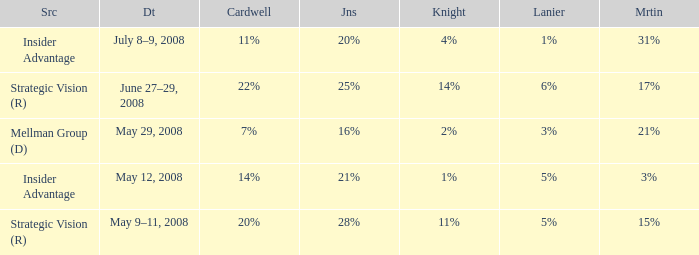What cardwell has an insider advantage and a knight of 1% 14%. I'm looking to parse the entire table for insights. Could you assist me with that? {'header': ['Src', 'Dt', 'Cardwell', 'Jns', 'Knight', 'Lanier', 'Mrtin'], 'rows': [['Insider Advantage', 'July 8–9, 2008', '11%', '20%', '4%', '1%', '31%'], ['Strategic Vision (R)', 'June 27–29, 2008', '22%', '25%', '14%', '6%', '17%'], ['Mellman Group (D)', 'May 29, 2008', '7%', '16%', '2%', '3%', '21%'], ['Insider Advantage', 'May 12, 2008', '14%', '21%', '1%', '5%', '3%'], ['Strategic Vision (R)', 'May 9–11, 2008', '20%', '28%', '11%', '5%', '15%']]} 